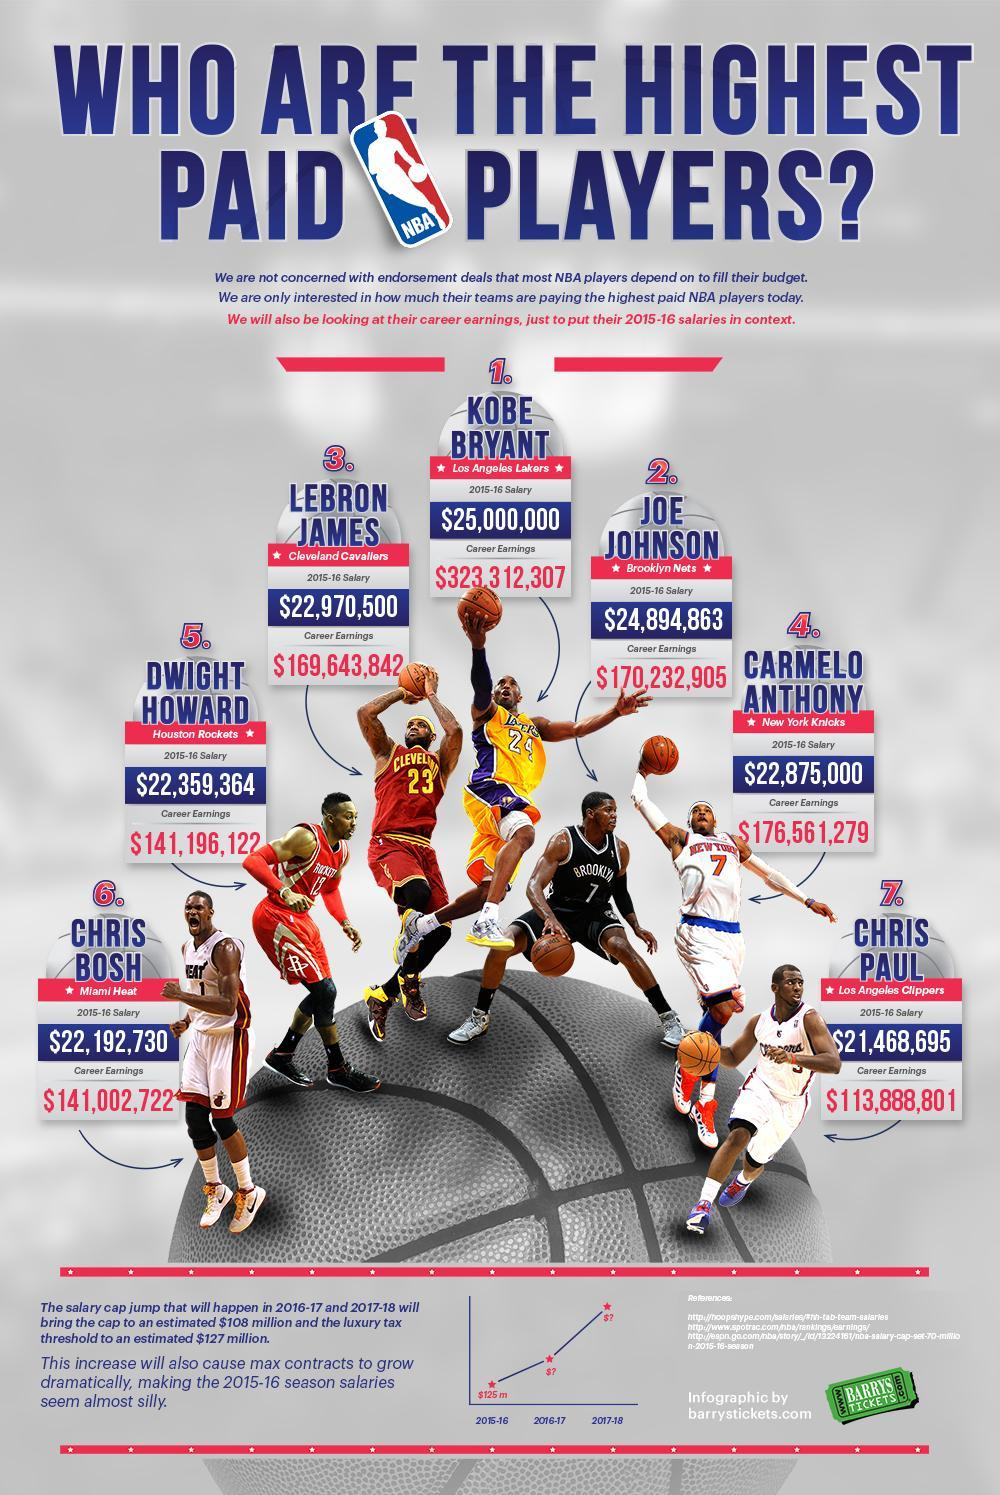WHat is the number written on the T Shirt of Joe Johnson
Answer the question with a short phrase. 7 What is the 2015-16 salary of Kobe Bryant $25,000,000 Who is at position 4 Carmelo Anthony What is the total career earnings in $ of Joe Johnson and Carmelo Anthony 346794184 Who is from New York Knicks Carmelo Anthony Which team does Chris Bosh belong to miami heat What is the total career earnings of Chris Paul $113,888,801 